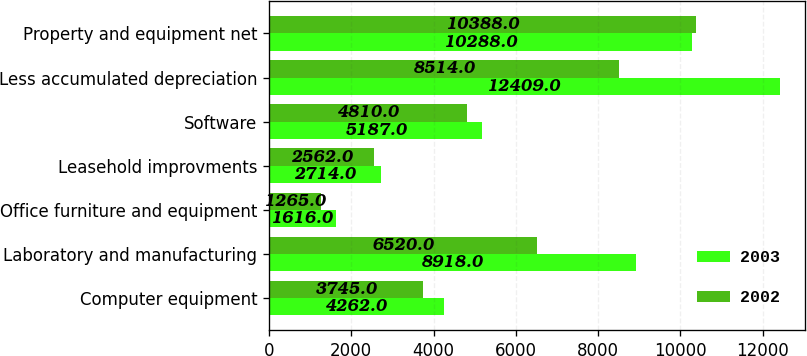<chart> <loc_0><loc_0><loc_500><loc_500><stacked_bar_chart><ecel><fcel>Computer equipment<fcel>Laboratory and manufacturing<fcel>Office furniture and equipment<fcel>Leasehold improvments<fcel>Software<fcel>Less accumulated depreciation<fcel>Property and equipment net<nl><fcel>2003<fcel>4262<fcel>8918<fcel>1616<fcel>2714<fcel>5187<fcel>12409<fcel>10288<nl><fcel>2002<fcel>3745<fcel>6520<fcel>1265<fcel>2562<fcel>4810<fcel>8514<fcel>10388<nl></chart> 